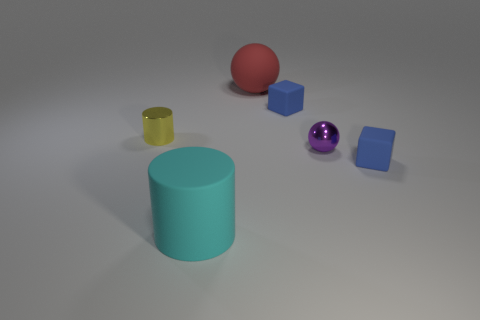How are the objects arranged in the image? The objects are spaced out across the surface with no apparent order. There is a mix of colors and shapes, such as spheres, cubes, and cylinders, that provide a variation in three-dimensional geometry, contributing to the visual diversity of the scene. 